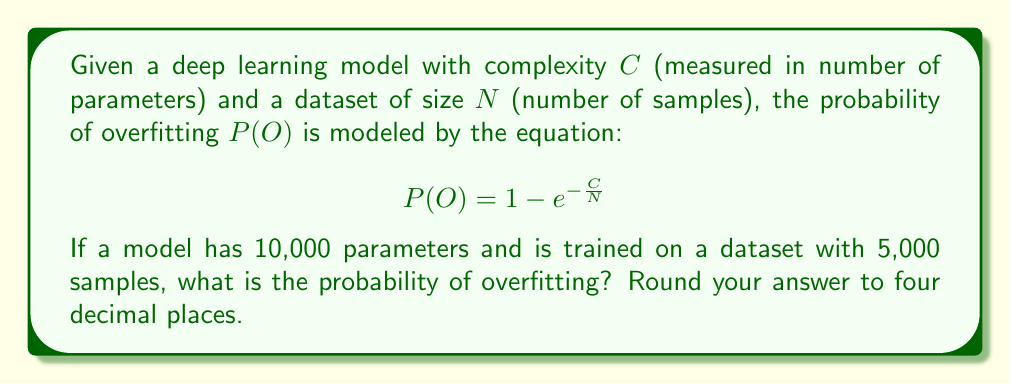Solve this math problem. Let's approach this step-by-step:

1) We are given the equation for the probability of overfitting:
   $$P(O) = 1 - e^{-\frac{C}{N}}$$

2) We know:
   $C = 10,000$ (number of parameters)
   $N = 5,000$ (number of samples)

3) Let's substitute these values into our equation:
   $$P(O) = 1 - e^{-\frac{10,000}{5,000}}$$

4) Simplify the fraction inside the exponent:
   $$P(O) = 1 - e^{-2}$$

5) Now, we need to calculate $e^{-2}$:
   $e^{-2} \approx 0.1353$

6) Subtract this from 1:
   $P(O) = 1 - 0.1353 = 0.8647$

7) Rounding to four decimal places:
   $P(O) \approx 0.8647$

This result indicates a high probability of overfitting, which is expected given that the number of parameters (model complexity) is twice the number of samples in the dataset.
Answer: $0.8647$ 